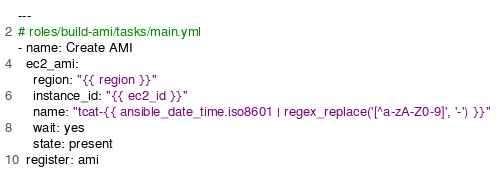<code> <loc_0><loc_0><loc_500><loc_500><_YAML_>---
# roles/build-ami/tasks/main.yml
- name: Create AMI
  ec2_ami:
    region: "{{ region }}"
    instance_id: "{{ ec2_id }}"
    name: "tcat-{{ ansible_date_time.iso8601 | regex_replace('[^a-zA-Z0-9]', '-') }}"
    wait: yes
    state: present
  register: ami
</code> 